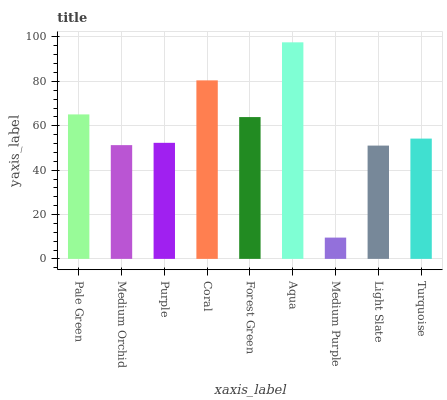Is Medium Purple the minimum?
Answer yes or no. Yes. Is Aqua the maximum?
Answer yes or no. Yes. Is Medium Orchid the minimum?
Answer yes or no. No. Is Medium Orchid the maximum?
Answer yes or no. No. Is Pale Green greater than Medium Orchid?
Answer yes or no. Yes. Is Medium Orchid less than Pale Green?
Answer yes or no. Yes. Is Medium Orchid greater than Pale Green?
Answer yes or no. No. Is Pale Green less than Medium Orchid?
Answer yes or no. No. Is Turquoise the high median?
Answer yes or no. Yes. Is Turquoise the low median?
Answer yes or no. Yes. Is Light Slate the high median?
Answer yes or no. No. Is Medium Purple the low median?
Answer yes or no. No. 